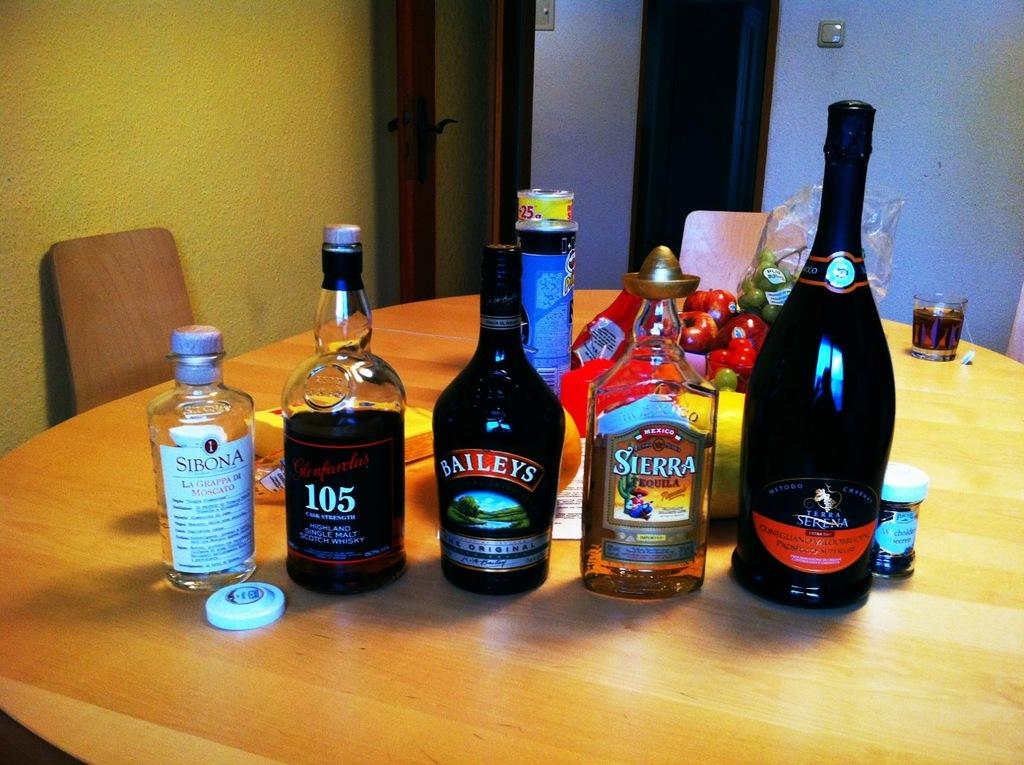<image>
Relay a brief, clear account of the picture shown. A collection of bottles on the table the middle one of baileys. 